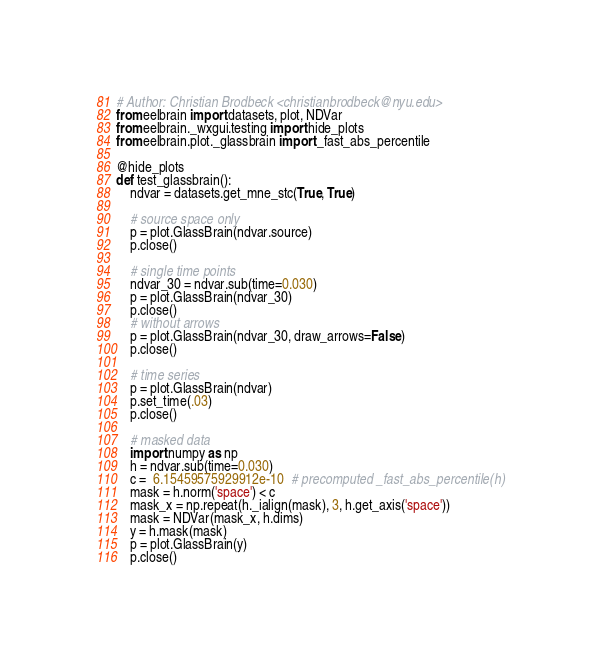<code> <loc_0><loc_0><loc_500><loc_500><_Python_># Author: Christian Brodbeck <christianbrodbeck@nyu.edu>
from eelbrain import datasets, plot, NDVar
from eelbrain._wxgui.testing import hide_plots
from eelbrain.plot._glassbrain import _fast_abs_percentile

@hide_plots
def test_glassbrain():
    ndvar = datasets.get_mne_stc(True, True)

    # source space only
    p = plot.GlassBrain(ndvar.source)
    p.close()

    # single time points
    ndvar_30 = ndvar.sub(time=0.030)
    p = plot.GlassBrain(ndvar_30)
    p.close()
    # without arrows
    p = plot.GlassBrain(ndvar_30, draw_arrows=False)
    p.close()

    # time series
    p = plot.GlassBrain(ndvar)
    p.set_time(.03)
    p.close()

    # masked data
    import numpy as np
    h = ndvar.sub(time=0.030)
    c =  6.15459575929912e-10  # precomputed _fast_abs_percentile(h)
    mask = h.norm('space') < c
    mask_x = np.repeat(h._ialign(mask), 3, h.get_axis('space'))
    mask = NDVar(mask_x, h.dims)
    y = h.mask(mask)
    p = plot.GlassBrain(y)
    p.close()
</code> 